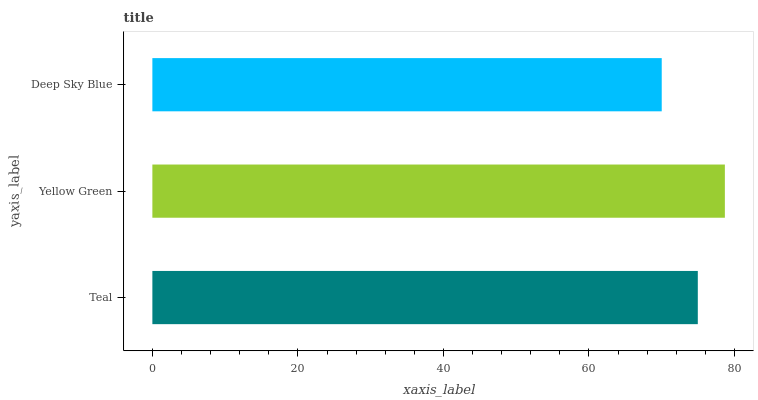Is Deep Sky Blue the minimum?
Answer yes or no. Yes. Is Yellow Green the maximum?
Answer yes or no. Yes. Is Yellow Green the minimum?
Answer yes or no. No. Is Deep Sky Blue the maximum?
Answer yes or no. No. Is Yellow Green greater than Deep Sky Blue?
Answer yes or no. Yes. Is Deep Sky Blue less than Yellow Green?
Answer yes or no. Yes. Is Deep Sky Blue greater than Yellow Green?
Answer yes or no. No. Is Yellow Green less than Deep Sky Blue?
Answer yes or no. No. Is Teal the high median?
Answer yes or no. Yes. Is Teal the low median?
Answer yes or no. Yes. Is Deep Sky Blue the high median?
Answer yes or no. No. Is Deep Sky Blue the low median?
Answer yes or no. No. 